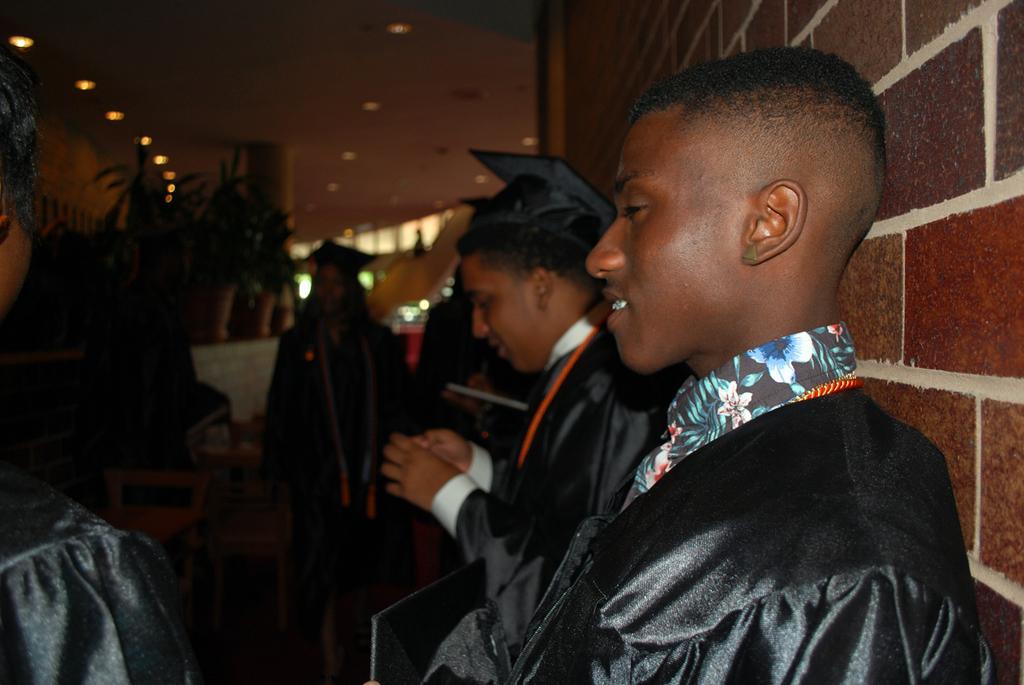Can you describe this image briefly? This picture describes about group of people, in the background we can see few plants and lights. 